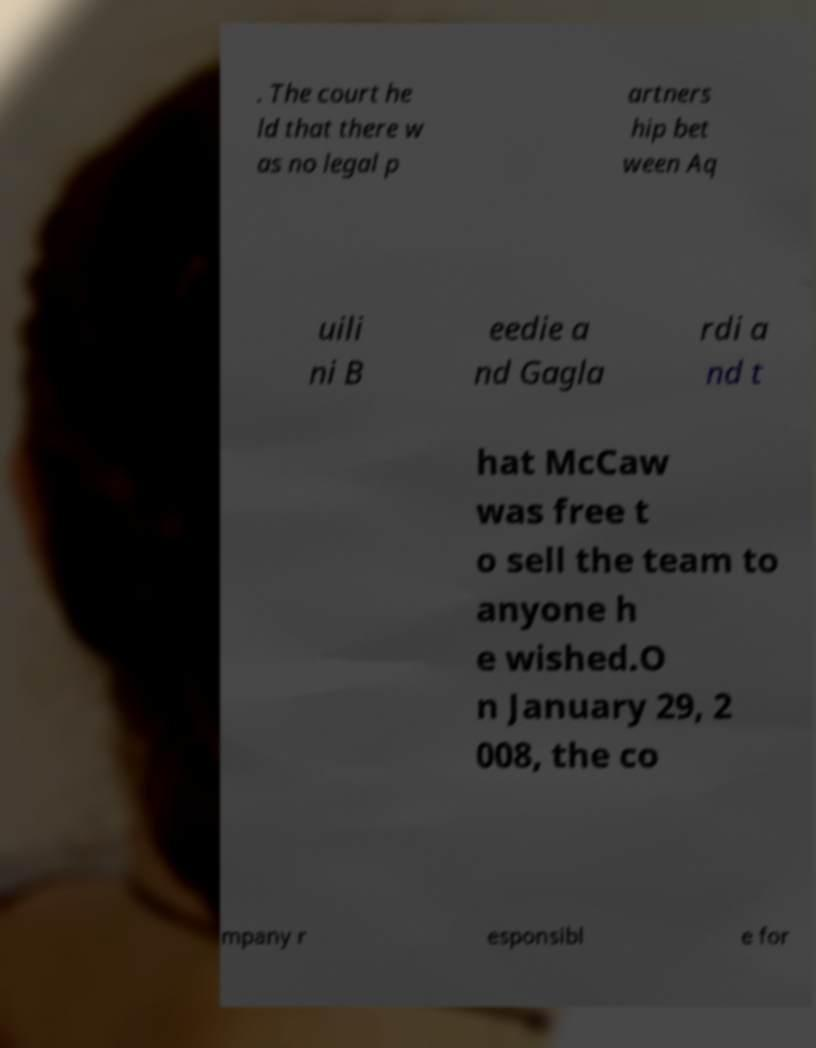Could you extract and type out the text from this image? . The court he ld that there w as no legal p artners hip bet ween Aq uili ni B eedie a nd Gagla rdi a nd t hat McCaw was free t o sell the team to anyone h e wished.O n January 29, 2 008, the co mpany r esponsibl e for 